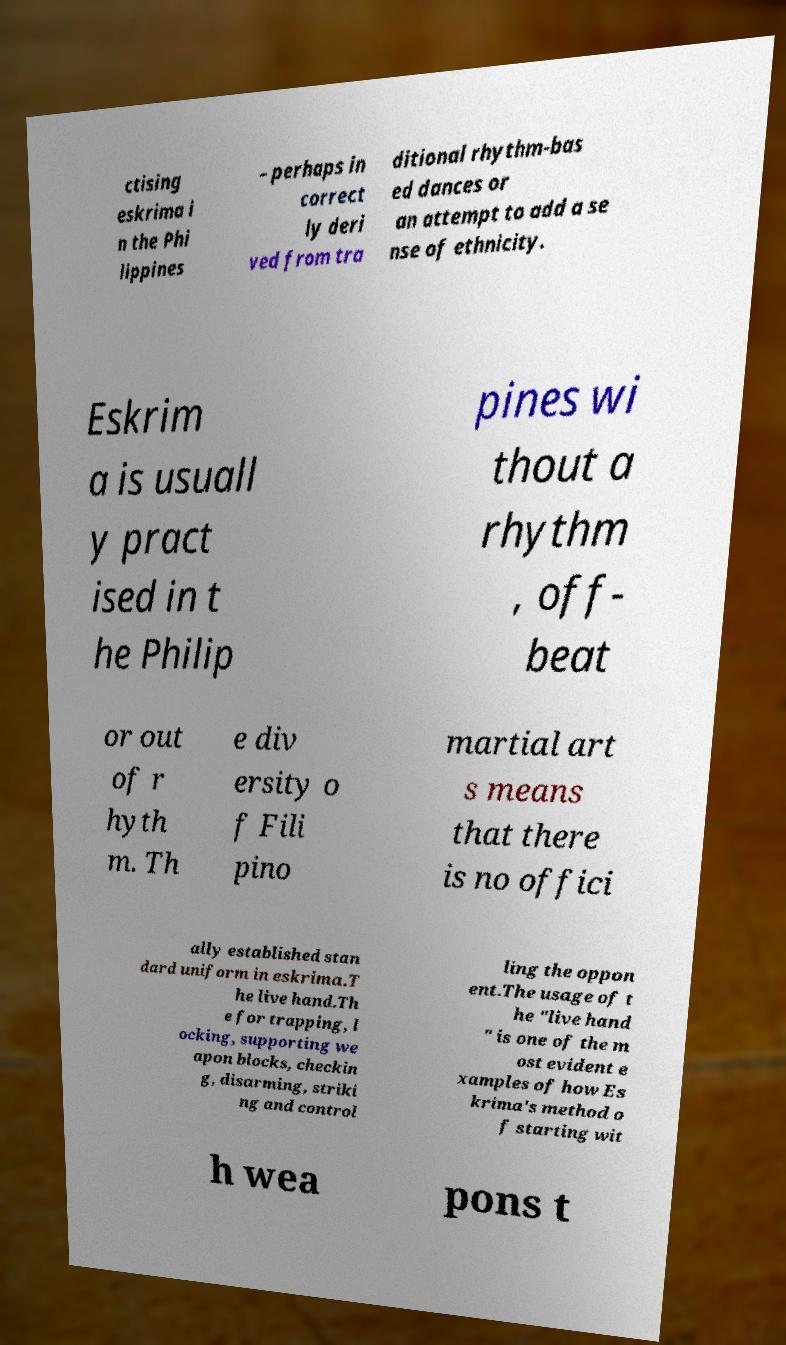Please read and relay the text visible in this image. What does it say? ctising eskrima i n the Phi lippines – perhaps in correct ly deri ved from tra ditional rhythm-bas ed dances or an attempt to add a se nse of ethnicity. Eskrim a is usuall y pract ised in t he Philip pines wi thout a rhythm , off- beat or out of r hyth m. Th e div ersity o f Fili pino martial art s means that there is no offici ally established stan dard uniform in eskrima.T he live hand.Th e for trapping, l ocking, supporting we apon blocks, checkin g, disarming, striki ng and control ling the oppon ent.The usage of t he "live hand " is one of the m ost evident e xamples of how Es krima's method o f starting wit h wea pons t 